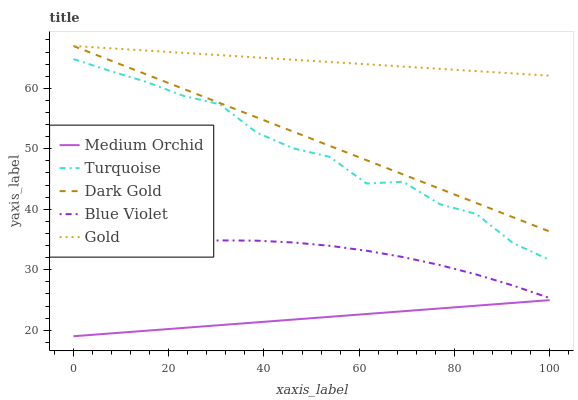Does Medium Orchid have the minimum area under the curve?
Answer yes or no. Yes. Does Gold have the maximum area under the curve?
Answer yes or no. Yes. Does Gold have the minimum area under the curve?
Answer yes or no. No. Does Medium Orchid have the maximum area under the curve?
Answer yes or no. No. Is Medium Orchid the smoothest?
Answer yes or no. Yes. Is Turquoise the roughest?
Answer yes or no. Yes. Is Gold the smoothest?
Answer yes or no. No. Is Gold the roughest?
Answer yes or no. No. Does Gold have the lowest value?
Answer yes or no. No. Does Medium Orchid have the highest value?
Answer yes or no. No. Is Turquoise less than Dark Gold?
Answer yes or no. Yes. Is Dark Gold greater than Turquoise?
Answer yes or no. Yes. Does Turquoise intersect Dark Gold?
Answer yes or no. No. 